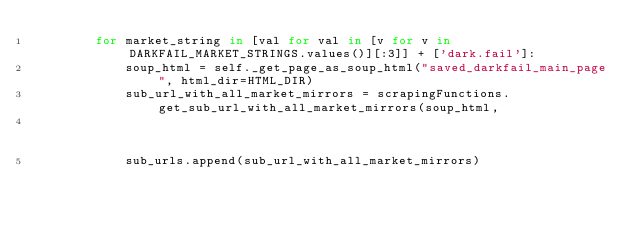<code> <loc_0><loc_0><loc_500><loc_500><_Python_>        for market_string in [val for val in [v for v in DARKFAIL_MARKET_STRINGS.values()][:3]] + ['dark.fail']:
            soup_html = self._get_page_as_soup_html("saved_darkfail_main_page", html_dir=HTML_DIR)
            sub_url_with_all_market_mirrors = scrapingFunctions.get_sub_url_with_all_market_mirrors(soup_html,
                                                                                                    market_string)
            sub_urls.append(sub_url_with_all_market_mirrors)
</code> 